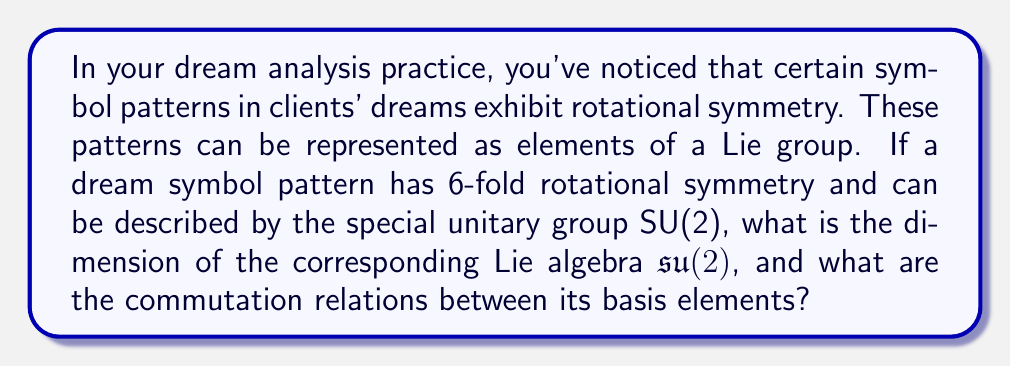Solve this math problem. To solve this problem, we need to understand the connection between Lie groups and Lie algebras, particularly for the special unitary group SU(2).

1. The special unitary group SU(2) is a 3-dimensional Lie group of 2×2 unitary matrices with determinant 1.

2. The Lie algebra $\mathfrak{su}(2)$ corresponds to the tangent space of SU(2) at the identity element.

3. The dimension of a Lie algebra is equal to the dimension of its corresponding Lie group. Therefore, dim($\mathfrak{su}(2)$) = 3.

4. The basis elements of $\mathfrak{su}(2)$ are typically represented by the Pauli matrices multiplied by $i/2$:

   $$X = \frac{i}{2}\begin{pmatrix} 0 & 1 \\ 1 & 0 \end{pmatrix}, \quad
     Y = \frac{i}{2}\begin{pmatrix} 0 & -i \\ i & 0 \end{pmatrix}, \quad
     Z = \frac{i}{2}\begin{pmatrix} 1 & 0 \\ 0 & -1 \end{pmatrix}$$

5. The commutation relations between these basis elements are:

   $$[X, Y] = Z, \quad [Y, Z] = X, \quad [Z, X] = Y$$

These commutation relations define the structure of the Lie algebra $\mathfrak{su}(2)$.

Note: The 6-fold rotational symmetry mentioned in the question is not directly related to the dimension or structure of $\mathfrak{su}(2)$, but it suggests that the dream symbols could be represented as elements of SU(2) that, when applied 6 times, return to the identity transformation.
Answer: The dimension of the Lie algebra $\mathfrak{su}(2)$ is 3, and the commutation relations between its basis elements $X$, $Y$, and $Z$ are:

$$[X, Y] = Z, \quad [Y, Z] = X, \quad [Z, X] = Y$$ 